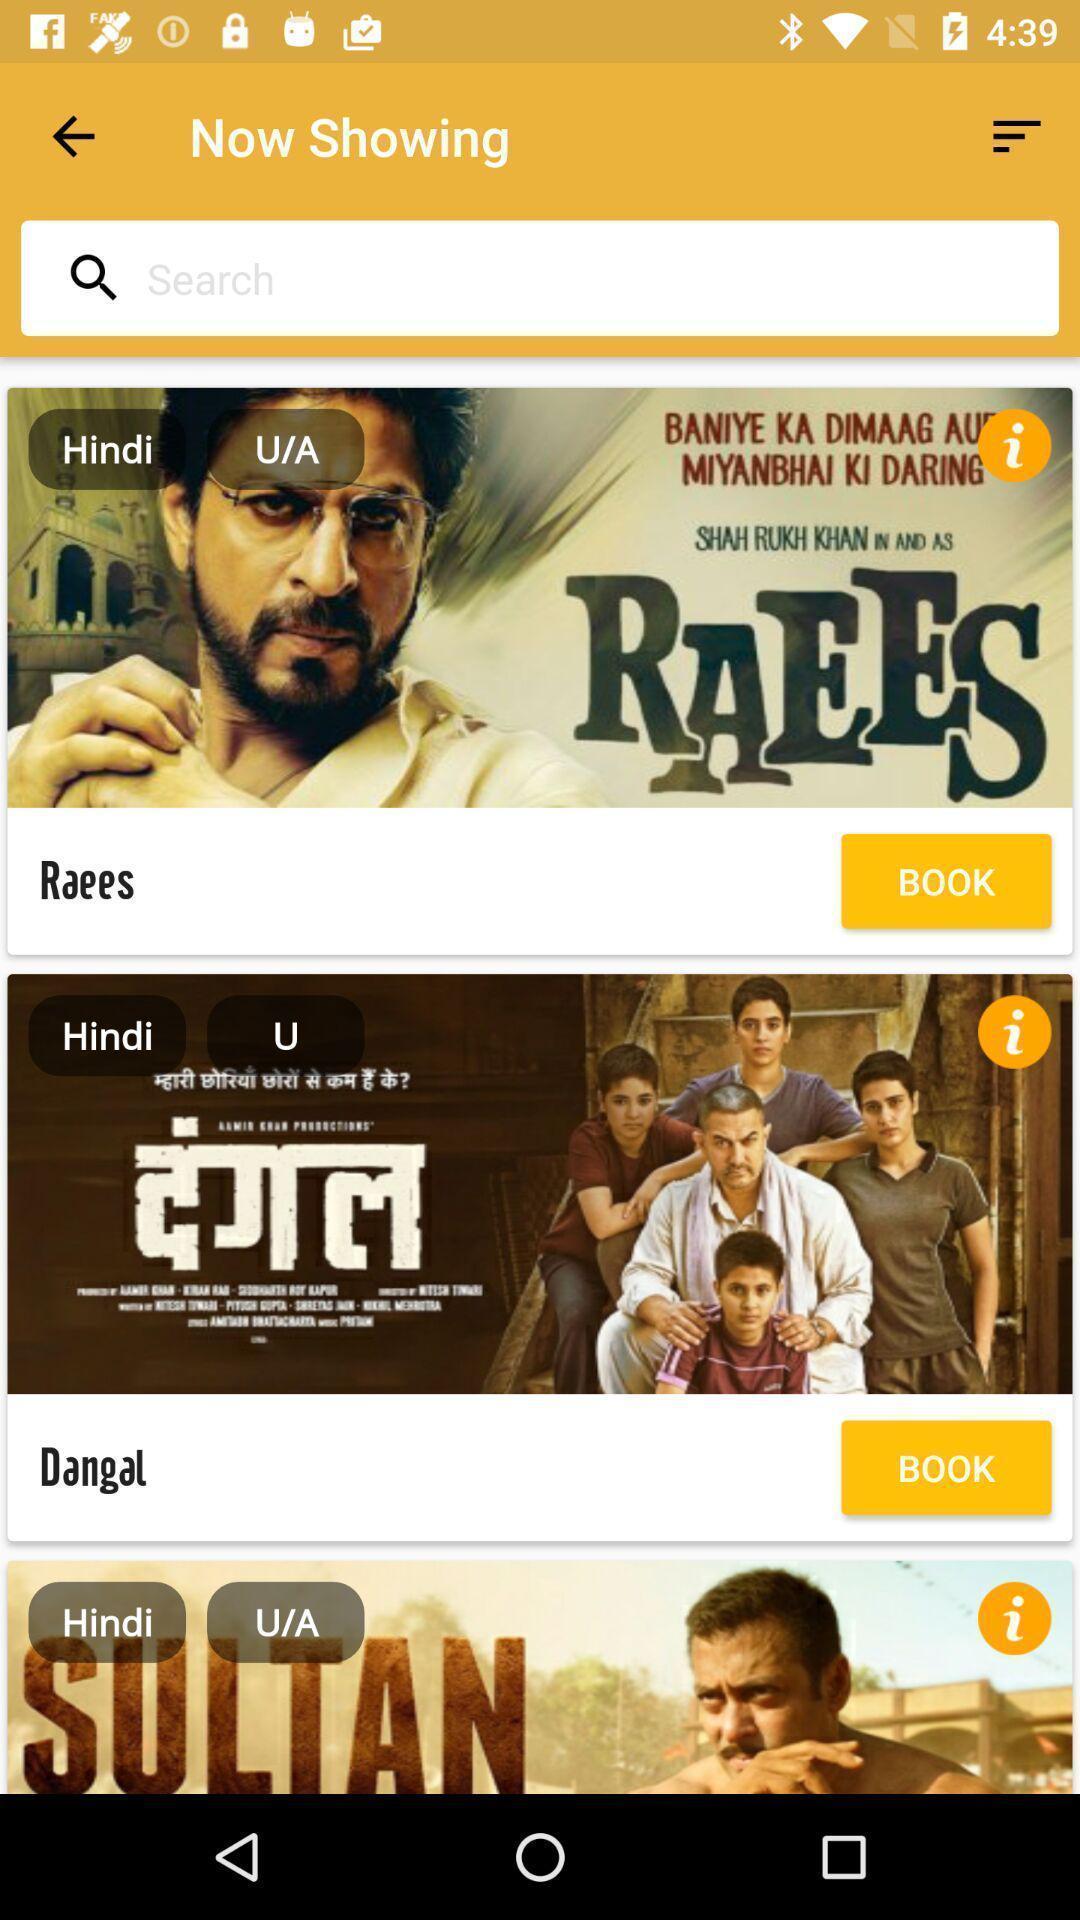Describe this image in words. Screen displaying various movies list in booking app. 